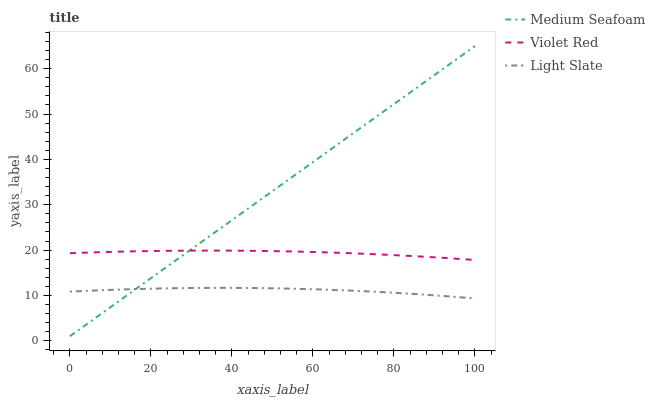Does Light Slate have the minimum area under the curve?
Answer yes or no. Yes. Does Medium Seafoam have the maximum area under the curve?
Answer yes or no. Yes. Does Violet Red have the minimum area under the curve?
Answer yes or no. No. Does Violet Red have the maximum area under the curve?
Answer yes or no. No. Is Medium Seafoam the smoothest?
Answer yes or no. Yes. Is Light Slate the roughest?
Answer yes or no. Yes. Is Violet Red the smoothest?
Answer yes or no. No. Is Violet Red the roughest?
Answer yes or no. No. Does Medium Seafoam have the lowest value?
Answer yes or no. Yes. Does Violet Red have the lowest value?
Answer yes or no. No. Does Medium Seafoam have the highest value?
Answer yes or no. Yes. Does Violet Red have the highest value?
Answer yes or no. No. Is Light Slate less than Violet Red?
Answer yes or no. Yes. Is Violet Red greater than Light Slate?
Answer yes or no. Yes. Does Medium Seafoam intersect Violet Red?
Answer yes or no. Yes. Is Medium Seafoam less than Violet Red?
Answer yes or no. No. Is Medium Seafoam greater than Violet Red?
Answer yes or no. No. Does Light Slate intersect Violet Red?
Answer yes or no. No. 